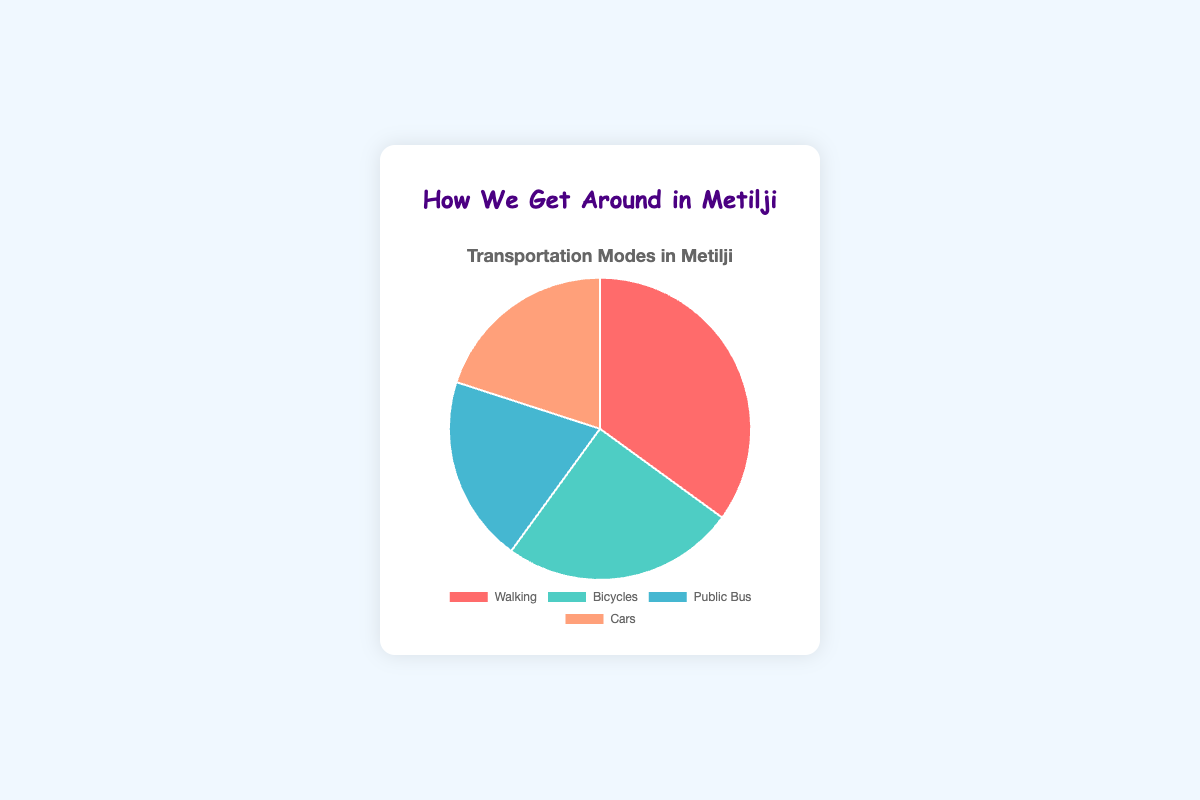What mode of transportation has the highest percentage in Metilji? Walking has the highest percentage at 35%.
Answer: Walking Which two modes of transportation have an equal percentage? Both Public Bus and Cars have the same percentage, which is 20%.
Answer: Public Bus and Cars What is the total percentage of non-motorized transportation modes? Non-motorized transportation modes include Walking and Bicycles. Adding their percentages: 35% + 25% = 60%.
Answer: 60% What is the least used mode of transportation? The least used modes are Public Bus and Cars, each with 20%.
Answer: Public Bus and Cars How much more popular is Walking compared to Bicycles? Walking is 35% and Bicycles is 25%. The difference is 35% - 25% = 10%.
Answer: 10% What mode of transportation is represented by the green color? Bicycles are represented by the green color as specified in the background colors of the pie chart.
Answer: Bicycles Out of Cars and Walking, which mode has the larger percentage? Walking has 35% while Cars have 20%, so Walking has the larger percentage.
Answer: Walking What is the combined percentage of motorized transportation modes? Motorized transportation modes include Public Bus and Cars. Adding their percentages: 20% + 20% = 40%.
Answer: 40% If one more mode of transportation were added with 10%, how would the total change? Adding a new mode with 10% would make the total percentage 100% + 10% = 110%.
Answer: 110% What is the average percentage of all reported modes of transportation? The sum of the percentages is 35% + 25% + 20% + 20% = 100%. The average percentage is 100% / 4 = 25%.
Answer: 25% 